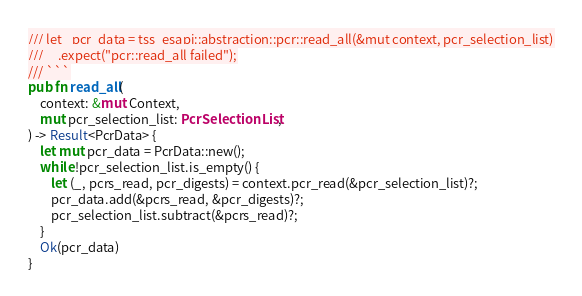Convert code to text. <code><loc_0><loc_0><loc_500><loc_500><_Rust_>/// let _pcr_data = tss_esapi::abstraction::pcr::read_all(&mut context, pcr_selection_list)
///     .expect("pcr::read_all failed");
/// ```
pub fn read_all(
    context: &mut Context,
    mut pcr_selection_list: PcrSelectionList,
) -> Result<PcrData> {
    let mut pcr_data = PcrData::new();
    while !pcr_selection_list.is_empty() {
        let (_, pcrs_read, pcr_digests) = context.pcr_read(&pcr_selection_list)?;
        pcr_data.add(&pcrs_read, &pcr_digests)?;
        pcr_selection_list.subtract(&pcrs_read)?;
    }
    Ok(pcr_data)
}
</code> 